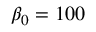Convert formula to latex. <formula><loc_0><loc_0><loc_500><loc_500>\beta _ { 0 } = 1 0 0</formula> 